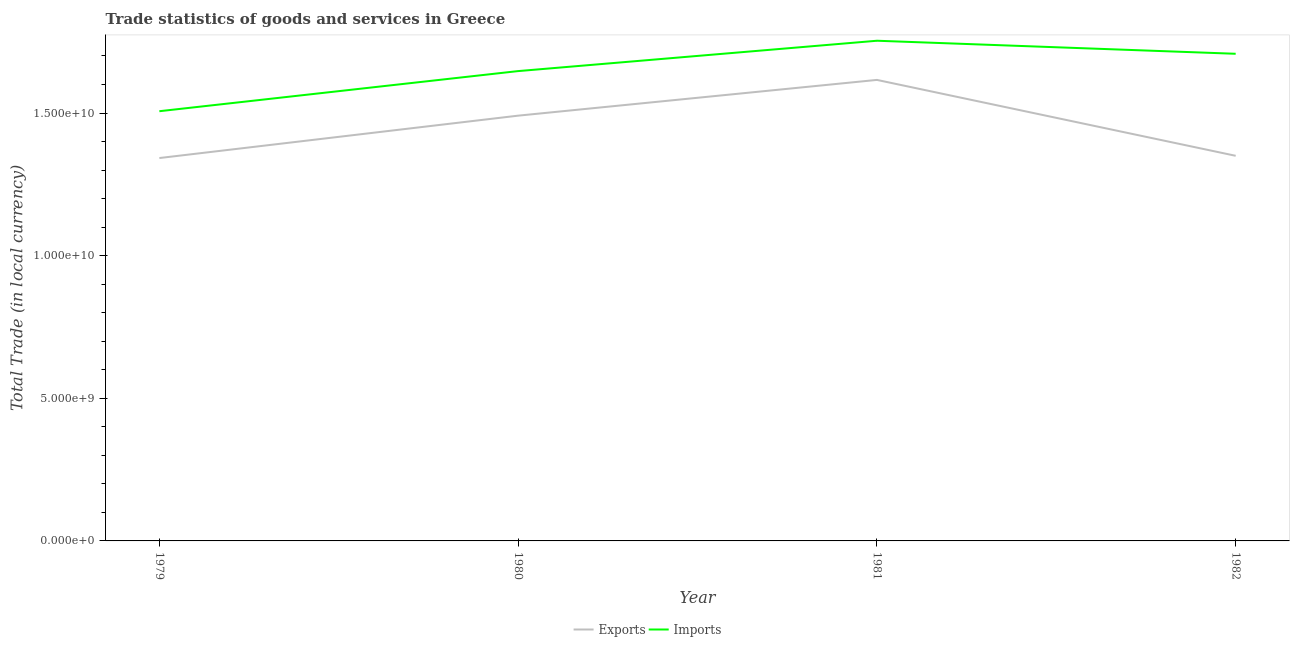How many different coloured lines are there?
Ensure brevity in your answer.  2. What is the export of goods and services in 1982?
Make the answer very short. 1.35e+1. Across all years, what is the maximum imports of goods and services?
Provide a succinct answer. 1.75e+1. Across all years, what is the minimum imports of goods and services?
Provide a succinct answer. 1.51e+1. In which year was the imports of goods and services minimum?
Ensure brevity in your answer.  1979. What is the total imports of goods and services in the graph?
Offer a very short reply. 6.61e+1. What is the difference between the export of goods and services in 1980 and that in 1982?
Your answer should be compact. 1.41e+09. What is the difference between the imports of goods and services in 1980 and the export of goods and services in 1981?
Offer a very short reply. 3.09e+08. What is the average export of goods and services per year?
Offer a terse response. 1.45e+1. In the year 1980, what is the difference between the imports of goods and services and export of goods and services?
Provide a succinct answer. 1.56e+09. What is the ratio of the imports of goods and services in 1980 to that in 1981?
Ensure brevity in your answer.  0.94. Is the export of goods and services in 1979 less than that in 1981?
Your answer should be compact. Yes. What is the difference between the highest and the second highest imports of goods and services?
Your answer should be very brief. 4.57e+08. What is the difference between the highest and the lowest imports of goods and services?
Offer a very short reply. 2.47e+09. In how many years, is the imports of goods and services greater than the average imports of goods and services taken over all years?
Offer a very short reply. 2. Is the sum of the export of goods and services in 1980 and 1981 greater than the maximum imports of goods and services across all years?
Your answer should be very brief. Yes. Does the imports of goods and services monotonically increase over the years?
Keep it short and to the point. No. Is the imports of goods and services strictly greater than the export of goods and services over the years?
Offer a terse response. Yes. Is the imports of goods and services strictly less than the export of goods and services over the years?
Keep it short and to the point. No. How many lines are there?
Provide a succinct answer. 2. What is the difference between two consecutive major ticks on the Y-axis?
Offer a very short reply. 5.00e+09. Does the graph contain grids?
Give a very brief answer. No. Where does the legend appear in the graph?
Your answer should be compact. Bottom center. What is the title of the graph?
Give a very brief answer. Trade statistics of goods and services in Greece. Does "Taxes on profits and capital gains" appear as one of the legend labels in the graph?
Ensure brevity in your answer.  No. What is the label or title of the Y-axis?
Keep it short and to the point. Total Trade (in local currency). What is the Total Trade (in local currency) in Exports in 1979?
Keep it short and to the point. 1.34e+1. What is the Total Trade (in local currency) of Imports in 1979?
Your answer should be compact. 1.51e+1. What is the Total Trade (in local currency) in Exports in 1980?
Make the answer very short. 1.49e+1. What is the Total Trade (in local currency) of Imports in 1980?
Your answer should be compact. 1.65e+1. What is the Total Trade (in local currency) in Exports in 1981?
Give a very brief answer. 1.62e+1. What is the Total Trade (in local currency) in Imports in 1981?
Give a very brief answer. 1.75e+1. What is the Total Trade (in local currency) in Exports in 1982?
Offer a terse response. 1.35e+1. What is the Total Trade (in local currency) of Imports in 1982?
Make the answer very short. 1.71e+1. Across all years, what is the maximum Total Trade (in local currency) in Exports?
Your response must be concise. 1.62e+1. Across all years, what is the maximum Total Trade (in local currency) of Imports?
Give a very brief answer. 1.75e+1. Across all years, what is the minimum Total Trade (in local currency) in Exports?
Ensure brevity in your answer.  1.34e+1. Across all years, what is the minimum Total Trade (in local currency) of Imports?
Your answer should be compact. 1.51e+1. What is the total Total Trade (in local currency) of Exports in the graph?
Ensure brevity in your answer.  5.80e+1. What is the total Total Trade (in local currency) of Imports in the graph?
Offer a very short reply. 6.61e+1. What is the difference between the Total Trade (in local currency) in Exports in 1979 and that in 1980?
Your answer should be very brief. -1.49e+09. What is the difference between the Total Trade (in local currency) in Imports in 1979 and that in 1980?
Provide a short and direct response. -1.41e+09. What is the difference between the Total Trade (in local currency) of Exports in 1979 and that in 1981?
Provide a short and direct response. -2.74e+09. What is the difference between the Total Trade (in local currency) in Imports in 1979 and that in 1981?
Your response must be concise. -2.47e+09. What is the difference between the Total Trade (in local currency) of Exports in 1979 and that in 1982?
Ensure brevity in your answer.  -7.85e+07. What is the difference between the Total Trade (in local currency) in Imports in 1979 and that in 1982?
Your answer should be compact. -2.01e+09. What is the difference between the Total Trade (in local currency) in Exports in 1980 and that in 1981?
Your answer should be compact. -1.25e+09. What is the difference between the Total Trade (in local currency) in Imports in 1980 and that in 1981?
Your answer should be very brief. -1.06e+09. What is the difference between the Total Trade (in local currency) of Exports in 1980 and that in 1982?
Your response must be concise. 1.41e+09. What is the difference between the Total Trade (in local currency) in Imports in 1980 and that in 1982?
Your answer should be compact. -6.07e+08. What is the difference between the Total Trade (in local currency) of Exports in 1981 and that in 1982?
Keep it short and to the point. 2.66e+09. What is the difference between the Total Trade (in local currency) of Imports in 1981 and that in 1982?
Your response must be concise. 4.57e+08. What is the difference between the Total Trade (in local currency) of Exports in 1979 and the Total Trade (in local currency) of Imports in 1980?
Offer a very short reply. -3.05e+09. What is the difference between the Total Trade (in local currency) in Exports in 1979 and the Total Trade (in local currency) in Imports in 1981?
Your response must be concise. -4.11e+09. What is the difference between the Total Trade (in local currency) in Exports in 1979 and the Total Trade (in local currency) in Imports in 1982?
Provide a short and direct response. -3.66e+09. What is the difference between the Total Trade (in local currency) of Exports in 1980 and the Total Trade (in local currency) of Imports in 1981?
Your answer should be very brief. -2.63e+09. What is the difference between the Total Trade (in local currency) in Exports in 1980 and the Total Trade (in local currency) in Imports in 1982?
Offer a very short reply. -2.17e+09. What is the difference between the Total Trade (in local currency) in Exports in 1981 and the Total Trade (in local currency) in Imports in 1982?
Your answer should be very brief. -9.16e+08. What is the average Total Trade (in local currency) of Exports per year?
Provide a short and direct response. 1.45e+1. What is the average Total Trade (in local currency) of Imports per year?
Your answer should be very brief. 1.65e+1. In the year 1979, what is the difference between the Total Trade (in local currency) of Exports and Total Trade (in local currency) of Imports?
Make the answer very short. -1.64e+09. In the year 1980, what is the difference between the Total Trade (in local currency) of Exports and Total Trade (in local currency) of Imports?
Ensure brevity in your answer.  -1.56e+09. In the year 1981, what is the difference between the Total Trade (in local currency) in Exports and Total Trade (in local currency) in Imports?
Your answer should be very brief. -1.37e+09. In the year 1982, what is the difference between the Total Trade (in local currency) in Exports and Total Trade (in local currency) in Imports?
Make the answer very short. -3.58e+09. What is the ratio of the Total Trade (in local currency) of Exports in 1979 to that in 1980?
Your answer should be very brief. 0.9. What is the ratio of the Total Trade (in local currency) in Imports in 1979 to that in 1980?
Provide a succinct answer. 0.91. What is the ratio of the Total Trade (in local currency) of Exports in 1979 to that in 1981?
Your answer should be compact. 0.83. What is the ratio of the Total Trade (in local currency) of Imports in 1979 to that in 1981?
Provide a short and direct response. 0.86. What is the ratio of the Total Trade (in local currency) of Exports in 1979 to that in 1982?
Your response must be concise. 0.99. What is the ratio of the Total Trade (in local currency) of Imports in 1979 to that in 1982?
Your answer should be very brief. 0.88. What is the ratio of the Total Trade (in local currency) in Exports in 1980 to that in 1981?
Keep it short and to the point. 0.92. What is the ratio of the Total Trade (in local currency) of Imports in 1980 to that in 1981?
Your response must be concise. 0.94. What is the ratio of the Total Trade (in local currency) of Exports in 1980 to that in 1982?
Provide a short and direct response. 1.1. What is the ratio of the Total Trade (in local currency) of Imports in 1980 to that in 1982?
Make the answer very short. 0.96. What is the ratio of the Total Trade (in local currency) of Exports in 1981 to that in 1982?
Provide a short and direct response. 1.2. What is the ratio of the Total Trade (in local currency) in Imports in 1981 to that in 1982?
Give a very brief answer. 1.03. What is the difference between the highest and the second highest Total Trade (in local currency) in Exports?
Make the answer very short. 1.25e+09. What is the difference between the highest and the second highest Total Trade (in local currency) of Imports?
Make the answer very short. 4.57e+08. What is the difference between the highest and the lowest Total Trade (in local currency) of Exports?
Keep it short and to the point. 2.74e+09. What is the difference between the highest and the lowest Total Trade (in local currency) of Imports?
Offer a terse response. 2.47e+09. 